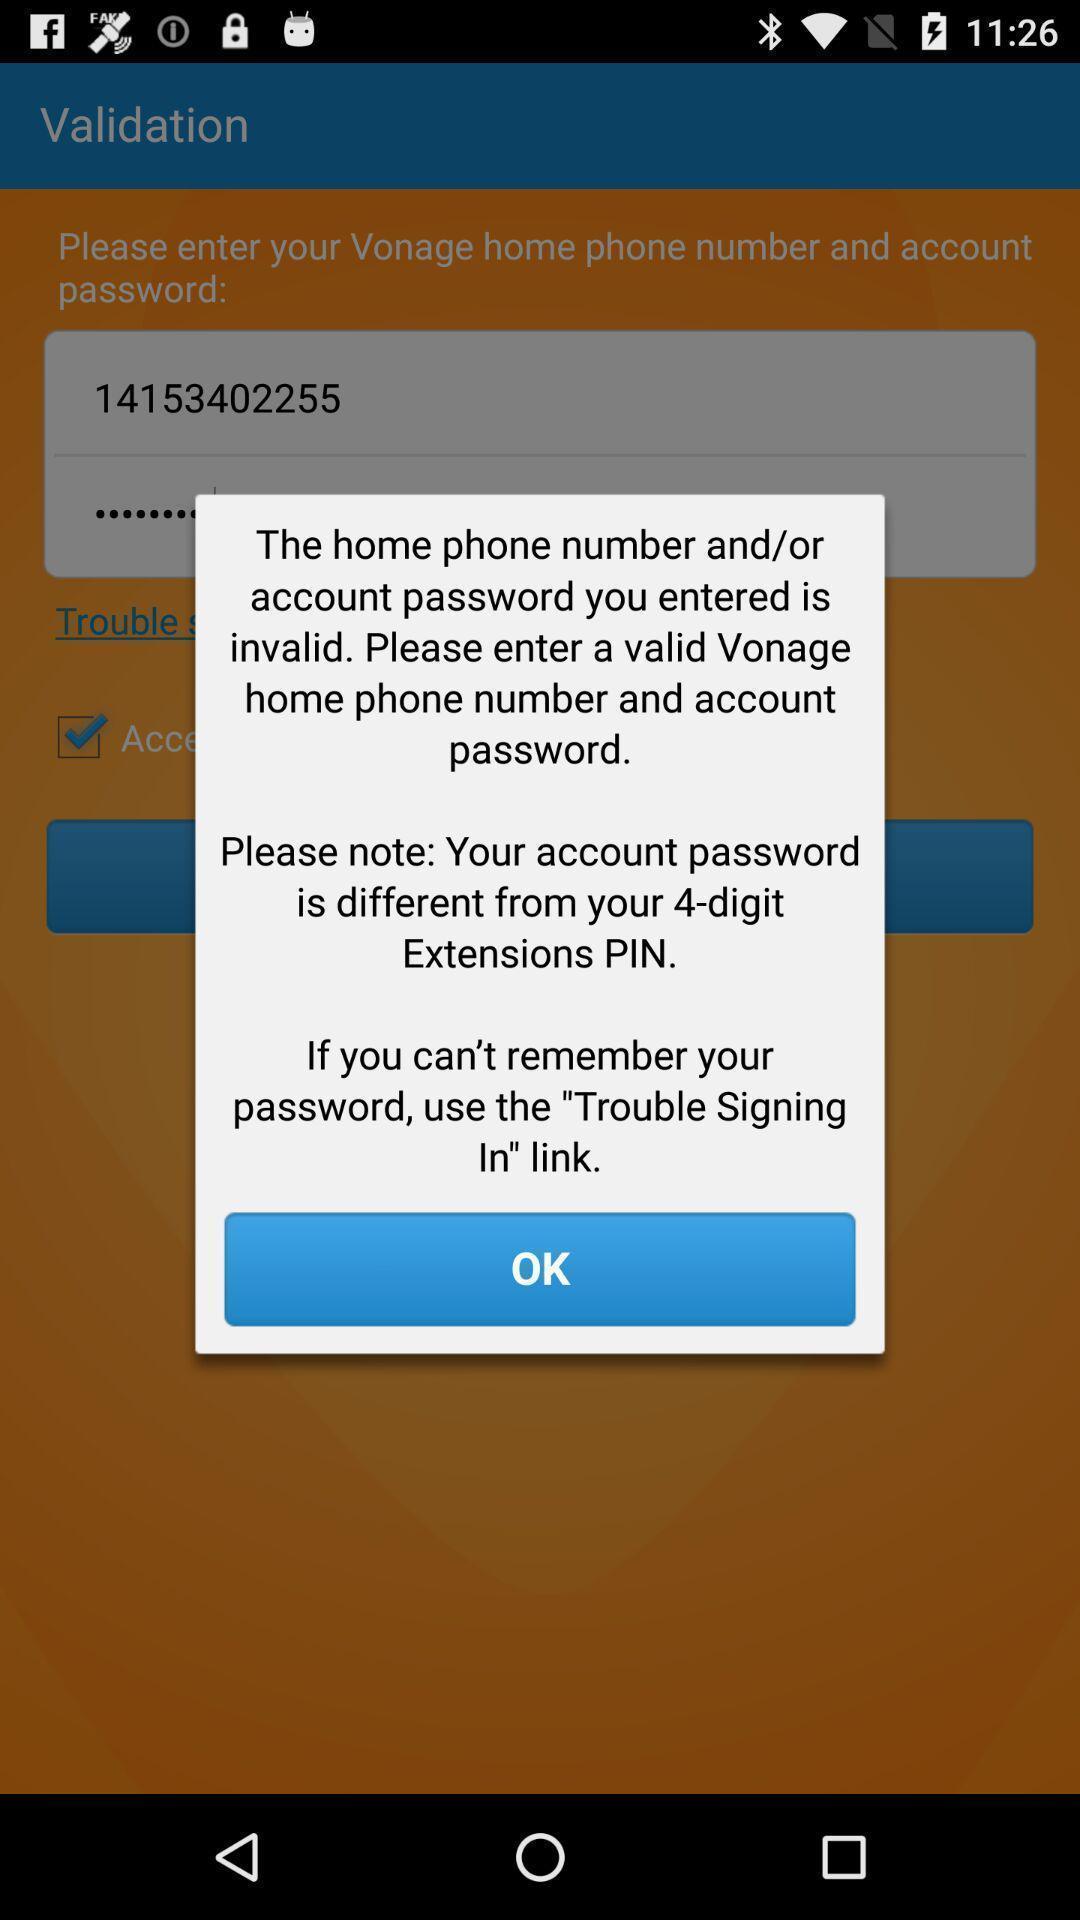What can you discern from this picture? Pop-up showing information about account and password. 